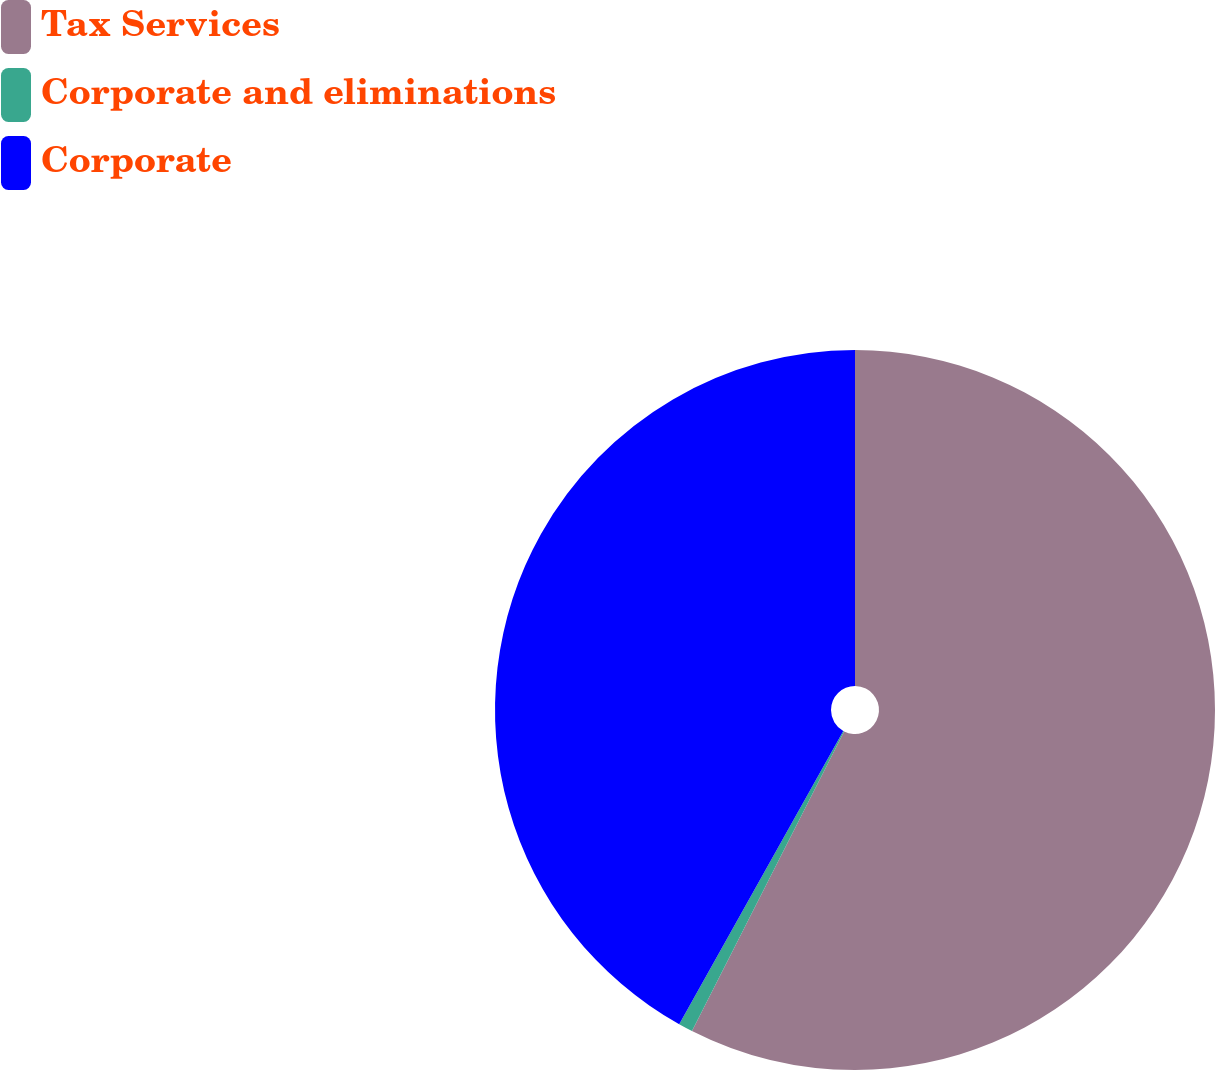<chart> <loc_0><loc_0><loc_500><loc_500><pie_chart><fcel>Tax Services<fcel>Corporate and eliminations<fcel>Corporate<nl><fcel>57.48%<fcel>0.64%<fcel>41.88%<nl></chart> 